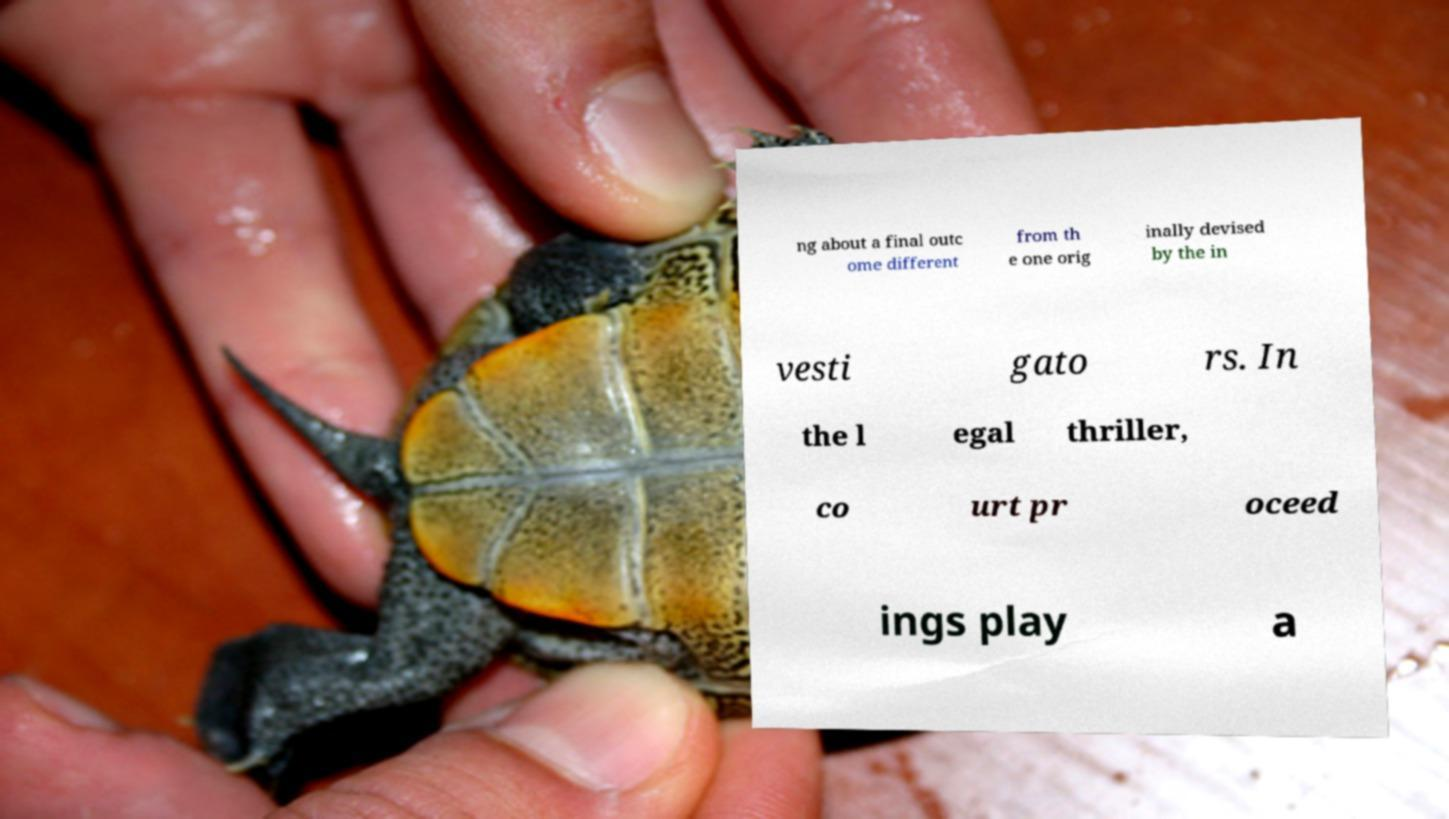Could you assist in decoding the text presented in this image and type it out clearly? ng about a final outc ome different from th e one orig inally devised by the in vesti gato rs. In the l egal thriller, co urt pr oceed ings play a 